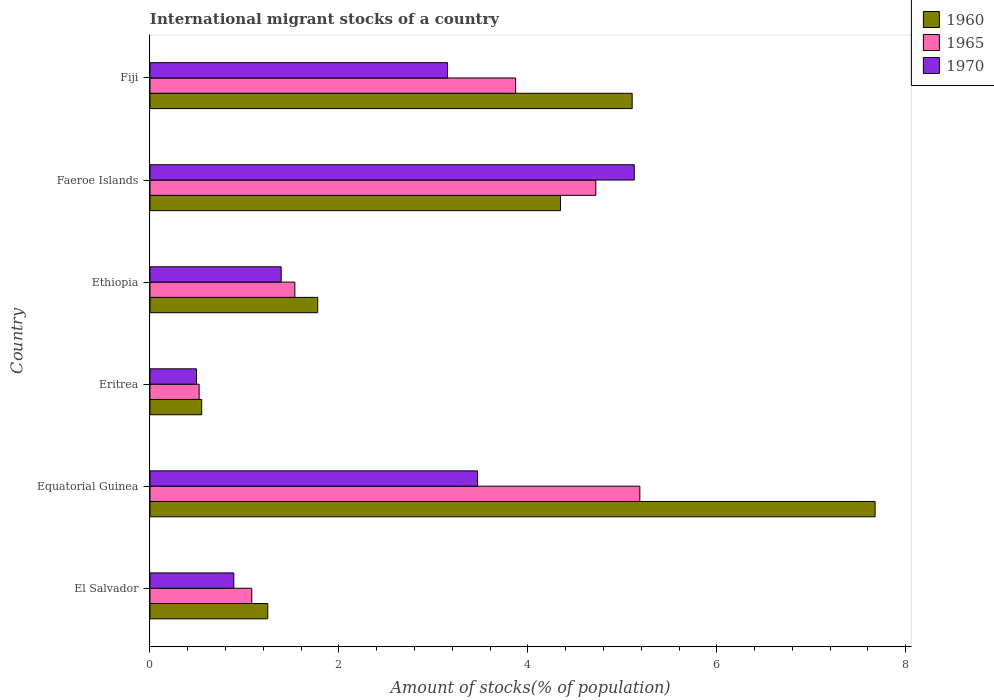How many different coloured bars are there?
Give a very brief answer. 3. Are the number of bars on each tick of the Y-axis equal?
Your answer should be very brief. Yes. How many bars are there on the 3rd tick from the top?
Offer a very short reply. 3. How many bars are there on the 3rd tick from the bottom?
Provide a short and direct response. 3. What is the label of the 3rd group of bars from the top?
Ensure brevity in your answer.  Ethiopia. In how many cases, is the number of bars for a given country not equal to the number of legend labels?
Provide a succinct answer. 0. What is the amount of stocks in in 1965 in Eritrea?
Keep it short and to the point. 0.52. Across all countries, what is the maximum amount of stocks in in 1970?
Provide a succinct answer. 5.13. Across all countries, what is the minimum amount of stocks in in 1965?
Your answer should be compact. 0.52. In which country was the amount of stocks in in 1960 maximum?
Ensure brevity in your answer.  Equatorial Guinea. In which country was the amount of stocks in in 1960 minimum?
Provide a succinct answer. Eritrea. What is the total amount of stocks in in 1970 in the graph?
Offer a very short reply. 14.51. What is the difference between the amount of stocks in in 1965 in Ethiopia and that in Fiji?
Your answer should be very brief. -2.34. What is the difference between the amount of stocks in in 1970 in El Salvador and the amount of stocks in in 1960 in Eritrea?
Provide a succinct answer. 0.34. What is the average amount of stocks in in 1970 per country?
Make the answer very short. 2.42. What is the difference between the amount of stocks in in 1960 and amount of stocks in in 1970 in Faeroe Islands?
Your response must be concise. -0.78. In how many countries, is the amount of stocks in in 1965 greater than 5.6 %?
Provide a short and direct response. 0. What is the ratio of the amount of stocks in in 1960 in Ethiopia to that in Fiji?
Your answer should be very brief. 0.35. Is the difference between the amount of stocks in in 1960 in Eritrea and Ethiopia greater than the difference between the amount of stocks in in 1970 in Eritrea and Ethiopia?
Keep it short and to the point. No. What is the difference between the highest and the second highest amount of stocks in in 1970?
Keep it short and to the point. 1.66. What is the difference between the highest and the lowest amount of stocks in in 1965?
Provide a short and direct response. 4.66. In how many countries, is the amount of stocks in in 1970 greater than the average amount of stocks in in 1970 taken over all countries?
Your answer should be very brief. 3. What does the 2nd bar from the bottom in Equatorial Guinea represents?
Provide a short and direct response. 1965. What is the difference between two consecutive major ticks on the X-axis?
Make the answer very short. 2. Are the values on the major ticks of X-axis written in scientific E-notation?
Your response must be concise. No. Where does the legend appear in the graph?
Provide a short and direct response. Top right. How many legend labels are there?
Your answer should be very brief. 3. How are the legend labels stacked?
Offer a very short reply. Vertical. What is the title of the graph?
Provide a short and direct response. International migrant stocks of a country. What is the label or title of the X-axis?
Provide a succinct answer. Amount of stocks(% of population). What is the Amount of stocks(% of population) in 1960 in El Salvador?
Keep it short and to the point. 1.25. What is the Amount of stocks(% of population) in 1965 in El Salvador?
Give a very brief answer. 1.08. What is the Amount of stocks(% of population) in 1970 in El Salvador?
Ensure brevity in your answer.  0.89. What is the Amount of stocks(% of population) of 1960 in Equatorial Guinea?
Offer a very short reply. 7.68. What is the Amount of stocks(% of population) of 1965 in Equatorial Guinea?
Offer a terse response. 5.19. What is the Amount of stocks(% of population) in 1970 in Equatorial Guinea?
Your answer should be very brief. 3.47. What is the Amount of stocks(% of population) in 1960 in Eritrea?
Offer a terse response. 0.55. What is the Amount of stocks(% of population) of 1965 in Eritrea?
Your answer should be very brief. 0.52. What is the Amount of stocks(% of population) in 1970 in Eritrea?
Give a very brief answer. 0.49. What is the Amount of stocks(% of population) in 1960 in Ethiopia?
Offer a very short reply. 1.78. What is the Amount of stocks(% of population) of 1965 in Ethiopia?
Your answer should be very brief. 1.53. What is the Amount of stocks(% of population) in 1970 in Ethiopia?
Keep it short and to the point. 1.39. What is the Amount of stocks(% of population) in 1960 in Faeroe Islands?
Keep it short and to the point. 4.35. What is the Amount of stocks(% of population) of 1965 in Faeroe Islands?
Make the answer very short. 4.72. What is the Amount of stocks(% of population) in 1970 in Faeroe Islands?
Offer a very short reply. 5.13. What is the Amount of stocks(% of population) of 1960 in Fiji?
Ensure brevity in your answer.  5.1. What is the Amount of stocks(% of population) in 1965 in Fiji?
Keep it short and to the point. 3.87. What is the Amount of stocks(% of population) in 1970 in Fiji?
Offer a very short reply. 3.15. Across all countries, what is the maximum Amount of stocks(% of population) in 1960?
Ensure brevity in your answer.  7.68. Across all countries, what is the maximum Amount of stocks(% of population) of 1965?
Provide a short and direct response. 5.19. Across all countries, what is the maximum Amount of stocks(% of population) in 1970?
Your answer should be compact. 5.13. Across all countries, what is the minimum Amount of stocks(% of population) in 1960?
Make the answer very short. 0.55. Across all countries, what is the minimum Amount of stocks(% of population) of 1965?
Your answer should be compact. 0.52. Across all countries, what is the minimum Amount of stocks(% of population) in 1970?
Keep it short and to the point. 0.49. What is the total Amount of stocks(% of population) in 1960 in the graph?
Ensure brevity in your answer.  20.69. What is the total Amount of stocks(% of population) in 1965 in the graph?
Provide a succinct answer. 16.91. What is the total Amount of stocks(% of population) in 1970 in the graph?
Your answer should be compact. 14.51. What is the difference between the Amount of stocks(% of population) in 1960 in El Salvador and that in Equatorial Guinea?
Your answer should be compact. -6.43. What is the difference between the Amount of stocks(% of population) of 1965 in El Salvador and that in Equatorial Guinea?
Your response must be concise. -4.11. What is the difference between the Amount of stocks(% of population) of 1970 in El Salvador and that in Equatorial Guinea?
Provide a succinct answer. -2.58. What is the difference between the Amount of stocks(% of population) of 1960 in El Salvador and that in Eritrea?
Keep it short and to the point. 0.7. What is the difference between the Amount of stocks(% of population) in 1965 in El Salvador and that in Eritrea?
Provide a succinct answer. 0.56. What is the difference between the Amount of stocks(% of population) in 1970 in El Salvador and that in Eritrea?
Provide a succinct answer. 0.39. What is the difference between the Amount of stocks(% of population) of 1960 in El Salvador and that in Ethiopia?
Keep it short and to the point. -0.53. What is the difference between the Amount of stocks(% of population) in 1965 in El Salvador and that in Ethiopia?
Your response must be concise. -0.46. What is the difference between the Amount of stocks(% of population) in 1970 in El Salvador and that in Ethiopia?
Keep it short and to the point. -0.5. What is the difference between the Amount of stocks(% of population) of 1960 in El Salvador and that in Faeroe Islands?
Make the answer very short. -3.1. What is the difference between the Amount of stocks(% of population) in 1965 in El Salvador and that in Faeroe Islands?
Make the answer very short. -3.64. What is the difference between the Amount of stocks(% of population) in 1970 in El Salvador and that in Faeroe Islands?
Your answer should be very brief. -4.24. What is the difference between the Amount of stocks(% of population) of 1960 in El Salvador and that in Fiji?
Your answer should be very brief. -3.86. What is the difference between the Amount of stocks(% of population) in 1965 in El Salvador and that in Fiji?
Offer a terse response. -2.79. What is the difference between the Amount of stocks(% of population) of 1970 in El Salvador and that in Fiji?
Offer a terse response. -2.26. What is the difference between the Amount of stocks(% of population) in 1960 in Equatorial Guinea and that in Eritrea?
Provide a succinct answer. 7.13. What is the difference between the Amount of stocks(% of population) in 1965 in Equatorial Guinea and that in Eritrea?
Keep it short and to the point. 4.66. What is the difference between the Amount of stocks(% of population) of 1970 in Equatorial Guinea and that in Eritrea?
Offer a very short reply. 2.97. What is the difference between the Amount of stocks(% of population) in 1960 in Equatorial Guinea and that in Ethiopia?
Provide a short and direct response. 5.9. What is the difference between the Amount of stocks(% of population) in 1965 in Equatorial Guinea and that in Ethiopia?
Your answer should be very brief. 3.65. What is the difference between the Amount of stocks(% of population) of 1970 in Equatorial Guinea and that in Ethiopia?
Offer a terse response. 2.08. What is the difference between the Amount of stocks(% of population) in 1960 in Equatorial Guinea and that in Faeroe Islands?
Give a very brief answer. 3.33. What is the difference between the Amount of stocks(% of population) in 1965 in Equatorial Guinea and that in Faeroe Islands?
Make the answer very short. 0.47. What is the difference between the Amount of stocks(% of population) of 1970 in Equatorial Guinea and that in Faeroe Islands?
Keep it short and to the point. -1.66. What is the difference between the Amount of stocks(% of population) of 1960 in Equatorial Guinea and that in Fiji?
Keep it short and to the point. 2.57. What is the difference between the Amount of stocks(% of population) in 1965 in Equatorial Guinea and that in Fiji?
Your answer should be very brief. 1.31. What is the difference between the Amount of stocks(% of population) of 1970 in Equatorial Guinea and that in Fiji?
Make the answer very short. 0.32. What is the difference between the Amount of stocks(% of population) of 1960 in Eritrea and that in Ethiopia?
Offer a very short reply. -1.23. What is the difference between the Amount of stocks(% of population) of 1965 in Eritrea and that in Ethiopia?
Provide a succinct answer. -1.01. What is the difference between the Amount of stocks(% of population) of 1970 in Eritrea and that in Ethiopia?
Offer a very short reply. -0.9. What is the difference between the Amount of stocks(% of population) in 1960 in Eritrea and that in Faeroe Islands?
Ensure brevity in your answer.  -3.8. What is the difference between the Amount of stocks(% of population) in 1965 in Eritrea and that in Faeroe Islands?
Ensure brevity in your answer.  -4.2. What is the difference between the Amount of stocks(% of population) of 1970 in Eritrea and that in Faeroe Islands?
Provide a short and direct response. -4.63. What is the difference between the Amount of stocks(% of population) of 1960 in Eritrea and that in Fiji?
Keep it short and to the point. -4.56. What is the difference between the Amount of stocks(% of population) in 1965 in Eritrea and that in Fiji?
Offer a terse response. -3.35. What is the difference between the Amount of stocks(% of population) in 1970 in Eritrea and that in Fiji?
Your answer should be very brief. -2.66. What is the difference between the Amount of stocks(% of population) of 1960 in Ethiopia and that in Faeroe Islands?
Keep it short and to the point. -2.57. What is the difference between the Amount of stocks(% of population) in 1965 in Ethiopia and that in Faeroe Islands?
Keep it short and to the point. -3.19. What is the difference between the Amount of stocks(% of population) in 1970 in Ethiopia and that in Faeroe Islands?
Offer a very short reply. -3.74. What is the difference between the Amount of stocks(% of population) of 1960 in Ethiopia and that in Fiji?
Offer a terse response. -3.33. What is the difference between the Amount of stocks(% of population) of 1965 in Ethiopia and that in Fiji?
Your answer should be very brief. -2.34. What is the difference between the Amount of stocks(% of population) in 1970 in Ethiopia and that in Fiji?
Your answer should be compact. -1.76. What is the difference between the Amount of stocks(% of population) of 1960 in Faeroe Islands and that in Fiji?
Make the answer very short. -0.76. What is the difference between the Amount of stocks(% of population) in 1965 in Faeroe Islands and that in Fiji?
Your response must be concise. 0.85. What is the difference between the Amount of stocks(% of population) of 1970 in Faeroe Islands and that in Fiji?
Your answer should be very brief. 1.98. What is the difference between the Amount of stocks(% of population) of 1960 in El Salvador and the Amount of stocks(% of population) of 1965 in Equatorial Guinea?
Your answer should be very brief. -3.94. What is the difference between the Amount of stocks(% of population) in 1960 in El Salvador and the Amount of stocks(% of population) in 1970 in Equatorial Guinea?
Ensure brevity in your answer.  -2.22. What is the difference between the Amount of stocks(% of population) of 1965 in El Salvador and the Amount of stocks(% of population) of 1970 in Equatorial Guinea?
Your answer should be compact. -2.39. What is the difference between the Amount of stocks(% of population) of 1960 in El Salvador and the Amount of stocks(% of population) of 1965 in Eritrea?
Make the answer very short. 0.73. What is the difference between the Amount of stocks(% of population) in 1960 in El Salvador and the Amount of stocks(% of population) in 1970 in Eritrea?
Provide a short and direct response. 0.75. What is the difference between the Amount of stocks(% of population) in 1965 in El Salvador and the Amount of stocks(% of population) in 1970 in Eritrea?
Provide a short and direct response. 0.58. What is the difference between the Amount of stocks(% of population) of 1960 in El Salvador and the Amount of stocks(% of population) of 1965 in Ethiopia?
Keep it short and to the point. -0.29. What is the difference between the Amount of stocks(% of population) of 1960 in El Salvador and the Amount of stocks(% of population) of 1970 in Ethiopia?
Ensure brevity in your answer.  -0.14. What is the difference between the Amount of stocks(% of population) in 1965 in El Salvador and the Amount of stocks(% of population) in 1970 in Ethiopia?
Offer a terse response. -0.31. What is the difference between the Amount of stocks(% of population) in 1960 in El Salvador and the Amount of stocks(% of population) in 1965 in Faeroe Islands?
Give a very brief answer. -3.47. What is the difference between the Amount of stocks(% of population) in 1960 in El Salvador and the Amount of stocks(% of population) in 1970 in Faeroe Islands?
Your answer should be very brief. -3.88. What is the difference between the Amount of stocks(% of population) in 1965 in El Salvador and the Amount of stocks(% of population) in 1970 in Faeroe Islands?
Make the answer very short. -4.05. What is the difference between the Amount of stocks(% of population) of 1960 in El Salvador and the Amount of stocks(% of population) of 1965 in Fiji?
Ensure brevity in your answer.  -2.62. What is the difference between the Amount of stocks(% of population) in 1960 in El Salvador and the Amount of stocks(% of population) in 1970 in Fiji?
Make the answer very short. -1.9. What is the difference between the Amount of stocks(% of population) of 1965 in El Salvador and the Amount of stocks(% of population) of 1970 in Fiji?
Your answer should be very brief. -2.07. What is the difference between the Amount of stocks(% of population) of 1960 in Equatorial Guinea and the Amount of stocks(% of population) of 1965 in Eritrea?
Offer a very short reply. 7.16. What is the difference between the Amount of stocks(% of population) of 1960 in Equatorial Guinea and the Amount of stocks(% of population) of 1970 in Eritrea?
Provide a succinct answer. 7.18. What is the difference between the Amount of stocks(% of population) of 1965 in Equatorial Guinea and the Amount of stocks(% of population) of 1970 in Eritrea?
Your answer should be very brief. 4.69. What is the difference between the Amount of stocks(% of population) of 1960 in Equatorial Guinea and the Amount of stocks(% of population) of 1965 in Ethiopia?
Offer a very short reply. 6.14. What is the difference between the Amount of stocks(% of population) of 1960 in Equatorial Guinea and the Amount of stocks(% of population) of 1970 in Ethiopia?
Ensure brevity in your answer.  6.29. What is the difference between the Amount of stocks(% of population) in 1965 in Equatorial Guinea and the Amount of stocks(% of population) in 1970 in Ethiopia?
Your response must be concise. 3.8. What is the difference between the Amount of stocks(% of population) of 1960 in Equatorial Guinea and the Amount of stocks(% of population) of 1965 in Faeroe Islands?
Your response must be concise. 2.96. What is the difference between the Amount of stocks(% of population) in 1960 in Equatorial Guinea and the Amount of stocks(% of population) in 1970 in Faeroe Islands?
Offer a very short reply. 2.55. What is the difference between the Amount of stocks(% of population) of 1965 in Equatorial Guinea and the Amount of stocks(% of population) of 1970 in Faeroe Islands?
Give a very brief answer. 0.06. What is the difference between the Amount of stocks(% of population) of 1960 in Equatorial Guinea and the Amount of stocks(% of population) of 1965 in Fiji?
Your answer should be compact. 3.81. What is the difference between the Amount of stocks(% of population) in 1960 in Equatorial Guinea and the Amount of stocks(% of population) in 1970 in Fiji?
Ensure brevity in your answer.  4.53. What is the difference between the Amount of stocks(% of population) in 1965 in Equatorial Guinea and the Amount of stocks(% of population) in 1970 in Fiji?
Your answer should be very brief. 2.04. What is the difference between the Amount of stocks(% of population) in 1960 in Eritrea and the Amount of stocks(% of population) in 1965 in Ethiopia?
Your response must be concise. -0.99. What is the difference between the Amount of stocks(% of population) in 1960 in Eritrea and the Amount of stocks(% of population) in 1970 in Ethiopia?
Provide a succinct answer. -0.84. What is the difference between the Amount of stocks(% of population) of 1965 in Eritrea and the Amount of stocks(% of population) of 1970 in Ethiopia?
Keep it short and to the point. -0.87. What is the difference between the Amount of stocks(% of population) of 1960 in Eritrea and the Amount of stocks(% of population) of 1965 in Faeroe Islands?
Provide a succinct answer. -4.17. What is the difference between the Amount of stocks(% of population) of 1960 in Eritrea and the Amount of stocks(% of population) of 1970 in Faeroe Islands?
Keep it short and to the point. -4.58. What is the difference between the Amount of stocks(% of population) of 1965 in Eritrea and the Amount of stocks(% of population) of 1970 in Faeroe Islands?
Give a very brief answer. -4.61. What is the difference between the Amount of stocks(% of population) in 1960 in Eritrea and the Amount of stocks(% of population) in 1965 in Fiji?
Ensure brevity in your answer.  -3.32. What is the difference between the Amount of stocks(% of population) in 1960 in Eritrea and the Amount of stocks(% of population) in 1970 in Fiji?
Make the answer very short. -2.6. What is the difference between the Amount of stocks(% of population) of 1965 in Eritrea and the Amount of stocks(% of population) of 1970 in Fiji?
Provide a succinct answer. -2.63. What is the difference between the Amount of stocks(% of population) in 1960 in Ethiopia and the Amount of stocks(% of population) in 1965 in Faeroe Islands?
Offer a very short reply. -2.94. What is the difference between the Amount of stocks(% of population) in 1960 in Ethiopia and the Amount of stocks(% of population) in 1970 in Faeroe Islands?
Provide a short and direct response. -3.35. What is the difference between the Amount of stocks(% of population) of 1965 in Ethiopia and the Amount of stocks(% of population) of 1970 in Faeroe Islands?
Ensure brevity in your answer.  -3.59. What is the difference between the Amount of stocks(% of population) of 1960 in Ethiopia and the Amount of stocks(% of population) of 1965 in Fiji?
Provide a succinct answer. -2.09. What is the difference between the Amount of stocks(% of population) in 1960 in Ethiopia and the Amount of stocks(% of population) in 1970 in Fiji?
Give a very brief answer. -1.37. What is the difference between the Amount of stocks(% of population) of 1965 in Ethiopia and the Amount of stocks(% of population) of 1970 in Fiji?
Your answer should be compact. -1.62. What is the difference between the Amount of stocks(% of population) in 1960 in Faeroe Islands and the Amount of stocks(% of population) in 1965 in Fiji?
Offer a terse response. 0.48. What is the difference between the Amount of stocks(% of population) of 1960 in Faeroe Islands and the Amount of stocks(% of population) of 1970 in Fiji?
Keep it short and to the point. 1.2. What is the difference between the Amount of stocks(% of population) of 1965 in Faeroe Islands and the Amount of stocks(% of population) of 1970 in Fiji?
Keep it short and to the point. 1.57. What is the average Amount of stocks(% of population) of 1960 per country?
Offer a terse response. 3.45. What is the average Amount of stocks(% of population) in 1965 per country?
Give a very brief answer. 2.82. What is the average Amount of stocks(% of population) of 1970 per country?
Keep it short and to the point. 2.42. What is the difference between the Amount of stocks(% of population) in 1960 and Amount of stocks(% of population) in 1965 in El Salvador?
Make the answer very short. 0.17. What is the difference between the Amount of stocks(% of population) in 1960 and Amount of stocks(% of population) in 1970 in El Salvador?
Your answer should be compact. 0.36. What is the difference between the Amount of stocks(% of population) in 1965 and Amount of stocks(% of population) in 1970 in El Salvador?
Offer a terse response. 0.19. What is the difference between the Amount of stocks(% of population) of 1960 and Amount of stocks(% of population) of 1965 in Equatorial Guinea?
Your answer should be very brief. 2.49. What is the difference between the Amount of stocks(% of population) of 1960 and Amount of stocks(% of population) of 1970 in Equatorial Guinea?
Offer a terse response. 4.21. What is the difference between the Amount of stocks(% of population) in 1965 and Amount of stocks(% of population) in 1970 in Equatorial Guinea?
Your response must be concise. 1.72. What is the difference between the Amount of stocks(% of population) in 1960 and Amount of stocks(% of population) in 1965 in Eritrea?
Make the answer very short. 0.03. What is the difference between the Amount of stocks(% of population) of 1960 and Amount of stocks(% of population) of 1970 in Eritrea?
Make the answer very short. 0.05. What is the difference between the Amount of stocks(% of population) in 1965 and Amount of stocks(% of population) in 1970 in Eritrea?
Offer a very short reply. 0.03. What is the difference between the Amount of stocks(% of population) of 1960 and Amount of stocks(% of population) of 1965 in Ethiopia?
Ensure brevity in your answer.  0.24. What is the difference between the Amount of stocks(% of population) in 1960 and Amount of stocks(% of population) in 1970 in Ethiopia?
Offer a very short reply. 0.39. What is the difference between the Amount of stocks(% of population) of 1965 and Amount of stocks(% of population) of 1970 in Ethiopia?
Your answer should be compact. 0.14. What is the difference between the Amount of stocks(% of population) of 1960 and Amount of stocks(% of population) of 1965 in Faeroe Islands?
Ensure brevity in your answer.  -0.37. What is the difference between the Amount of stocks(% of population) in 1960 and Amount of stocks(% of population) in 1970 in Faeroe Islands?
Your answer should be very brief. -0.78. What is the difference between the Amount of stocks(% of population) of 1965 and Amount of stocks(% of population) of 1970 in Faeroe Islands?
Offer a terse response. -0.41. What is the difference between the Amount of stocks(% of population) in 1960 and Amount of stocks(% of population) in 1965 in Fiji?
Ensure brevity in your answer.  1.23. What is the difference between the Amount of stocks(% of population) of 1960 and Amount of stocks(% of population) of 1970 in Fiji?
Make the answer very short. 1.95. What is the difference between the Amount of stocks(% of population) of 1965 and Amount of stocks(% of population) of 1970 in Fiji?
Offer a terse response. 0.72. What is the ratio of the Amount of stocks(% of population) of 1960 in El Salvador to that in Equatorial Guinea?
Offer a terse response. 0.16. What is the ratio of the Amount of stocks(% of population) in 1965 in El Salvador to that in Equatorial Guinea?
Give a very brief answer. 0.21. What is the ratio of the Amount of stocks(% of population) in 1970 in El Salvador to that in Equatorial Guinea?
Your response must be concise. 0.26. What is the ratio of the Amount of stocks(% of population) in 1960 in El Salvador to that in Eritrea?
Give a very brief answer. 2.28. What is the ratio of the Amount of stocks(% of population) in 1965 in El Salvador to that in Eritrea?
Provide a short and direct response. 2.07. What is the ratio of the Amount of stocks(% of population) in 1970 in El Salvador to that in Eritrea?
Offer a terse response. 1.8. What is the ratio of the Amount of stocks(% of population) of 1960 in El Salvador to that in Ethiopia?
Provide a succinct answer. 0.7. What is the ratio of the Amount of stocks(% of population) in 1965 in El Salvador to that in Ethiopia?
Your response must be concise. 0.7. What is the ratio of the Amount of stocks(% of population) of 1970 in El Salvador to that in Ethiopia?
Your answer should be compact. 0.64. What is the ratio of the Amount of stocks(% of population) of 1960 in El Salvador to that in Faeroe Islands?
Provide a short and direct response. 0.29. What is the ratio of the Amount of stocks(% of population) in 1965 in El Salvador to that in Faeroe Islands?
Your response must be concise. 0.23. What is the ratio of the Amount of stocks(% of population) of 1970 in El Salvador to that in Faeroe Islands?
Your answer should be very brief. 0.17. What is the ratio of the Amount of stocks(% of population) of 1960 in El Salvador to that in Fiji?
Give a very brief answer. 0.24. What is the ratio of the Amount of stocks(% of population) in 1965 in El Salvador to that in Fiji?
Offer a very short reply. 0.28. What is the ratio of the Amount of stocks(% of population) in 1970 in El Salvador to that in Fiji?
Offer a terse response. 0.28. What is the ratio of the Amount of stocks(% of population) in 1960 in Equatorial Guinea to that in Eritrea?
Ensure brevity in your answer.  14.03. What is the ratio of the Amount of stocks(% of population) in 1965 in Equatorial Guinea to that in Eritrea?
Your response must be concise. 9.97. What is the ratio of the Amount of stocks(% of population) in 1970 in Equatorial Guinea to that in Eritrea?
Offer a terse response. 7.04. What is the ratio of the Amount of stocks(% of population) of 1960 in Equatorial Guinea to that in Ethiopia?
Give a very brief answer. 4.32. What is the ratio of the Amount of stocks(% of population) of 1965 in Equatorial Guinea to that in Ethiopia?
Your answer should be very brief. 3.38. What is the ratio of the Amount of stocks(% of population) of 1970 in Equatorial Guinea to that in Ethiopia?
Ensure brevity in your answer.  2.5. What is the ratio of the Amount of stocks(% of population) of 1960 in Equatorial Guinea to that in Faeroe Islands?
Provide a succinct answer. 1.77. What is the ratio of the Amount of stocks(% of population) in 1965 in Equatorial Guinea to that in Faeroe Islands?
Keep it short and to the point. 1.1. What is the ratio of the Amount of stocks(% of population) of 1970 in Equatorial Guinea to that in Faeroe Islands?
Your answer should be very brief. 0.68. What is the ratio of the Amount of stocks(% of population) of 1960 in Equatorial Guinea to that in Fiji?
Your answer should be very brief. 1.5. What is the ratio of the Amount of stocks(% of population) of 1965 in Equatorial Guinea to that in Fiji?
Ensure brevity in your answer.  1.34. What is the ratio of the Amount of stocks(% of population) in 1970 in Equatorial Guinea to that in Fiji?
Offer a terse response. 1.1. What is the ratio of the Amount of stocks(% of population) in 1960 in Eritrea to that in Ethiopia?
Give a very brief answer. 0.31. What is the ratio of the Amount of stocks(% of population) in 1965 in Eritrea to that in Ethiopia?
Provide a succinct answer. 0.34. What is the ratio of the Amount of stocks(% of population) of 1970 in Eritrea to that in Ethiopia?
Give a very brief answer. 0.35. What is the ratio of the Amount of stocks(% of population) of 1960 in Eritrea to that in Faeroe Islands?
Offer a very short reply. 0.13. What is the ratio of the Amount of stocks(% of population) in 1965 in Eritrea to that in Faeroe Islands?
Offer a very short reply. 0.11. What is the ratio of the Amount of stocks(% of population) in 1970 in Eritrea to that in Faeroe Islands?
Your answer should be very brief. 0.1. What is the ratio of the Amount of stocks(% of population) in 1960 in Eritrea to that in Fiji?
Provide a succinct answer. 0.11. What is the ratio of the Amount of stocks(% of population) in 1965 in Eritrea to that in Fiji?
Make the answer very short. 0.13. What is the ratio of the Amount of stocks(% of population) in 1970 in Eritrea to that in Fiji?
Your answer should be very brief. 0.16. What is the ratio of the Amount of stocks(% of population) of 1960 in Ethiopia to that in Faeroe Islands?
Give a very brief answer. 0.41. What is the ratio of the Amount of stocks(% of population) of 1965 in Ethiopia to that in Faeroe Islands?
Offer a terse response. 0.32. What is the ratio of the Amount of stocks(% of population) of 1970 in Ethiopia to that in Faeroe Islands?
Keep it short and to the point. 0.27. What is the ratio of the Amount of stocks(% of population) of 1960 in Ethiopia to that in Fiji?
Keep it short and to the point. 0.35. What is the ratio of the Amount of stocks(% of population) of 1965 in Ethiopia to that in Fiji?
Keep it short and to the point. 0.4. What is the ratio of the Amount of stocks(% of population) of 1970 in Ethiopia to that in Fiji?
Keep it short and to the point. 0.44. What is the ratio of the Amount of stocks(% of population) in 1960 in Faeroe Islands to that in Fiji?
Make the answer very short. 0.85. What is the ratio of the Amount of stocks(% of population) in 1965 in Faeroe Islands to that in Fiji?
Your answer should be very brief. 1.22. What is the ratio of the Amount of stocks(% of population) in 1970 in Faeroe Islands to that in Fiji?
Your response must be concise. 1.63. What is the difference between the highest and the second highest Amount of stocks(% of population) of 1960?
Make the answer very short. 2.57. What is the difference between the highest and the second highest Amount of stocks(% of population) of 1965?
Keep it short and to the point. 0.47. What is the difference between the highest and the second highest Amount of stocks(% of population) of 1970?
Give a very brief answer. 1.66. What is the difference between the highest and the lowest Amount of stocks(% of population) of 1960?
Provide a succinct answer. 7.13. What is the difference between the highest and the lowest Amount of stocks(% of population) in 1965?
Your answer should be compact. 4.66. What is the difference between the highest and the lowest Amount of stocks(% of population) in 1970?
Your response must be concise. 4.63. 